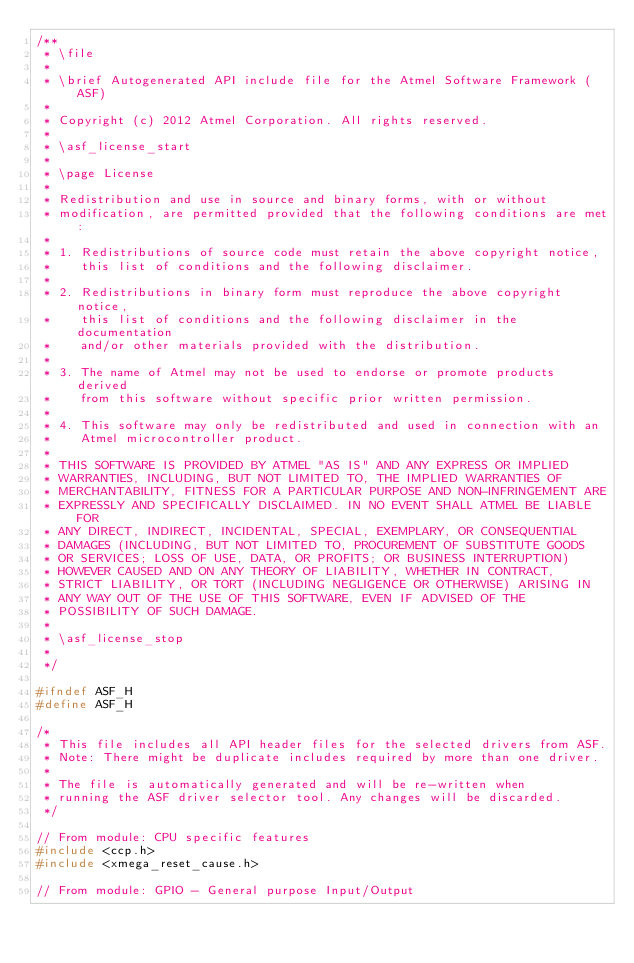Convert code to text. <code><loc_0><loc_0><loc_500><loc_500><_C_>/**
 * \file
 *
 * \brief Autogenerated API include file for the Atmel Software Framework (ASF)
 *
 * Copyright (c) 2012 Atmel Corporation. All rights reserved.
 *
 * \asf_license_start
 *
 * \page License
 *
 * Redistribution and use in source and binary forms, with or without
 * modification, are permitted provided that the following conditions are met:
 *
 * 1. Redistributions of source code must retain the above copyright notice,
 *    this list of conditions and the following disclaimer.
 *
 * 2. Redistributions in binary form must reproduce the above copyright notice,
 *    this list of conditions and the following disclaimer in the documentation
 *    and/or other materials provided with the distribution.
 *
 * 3. The name of Atmel may not be used to endorse or promote products derived
 *    from this software without specific prior written permission.
 *
 * 4. This software may only be redistributed and used in connection with an
 *    Atmel microcontroller product.
 *
 * THIS SOFTWARE IS PROVIDED BY ATMEL "AS IS" AND ANY EXPRESS OR IMPLIED
 * WARRANTIES, INCLUDING, BUT NOT LIMITED TO, THE IMPLIED WARRANTIES OF
 * MERCHANTABILITY, FITNESS FOR A PARTICULAR PURPOSE AND NON-INFRINGEMENT ARE
 * EXPRESSLY AND SPECIFICALLY DISCLAIMED. IN NO EVENT SHALL ATMEL BE LIABLE FOR
 * ANY DIRECT, INDIRECT, INCIDENTAL, SPECIAL, EXEMPLARY, OR CONSEQUENTIAL
 * DAMAGES (INCLUDING, BUT NOT LIMITED TO, PROCUREMENT OF SUBSTITUTE GOODS
 * OR SERVICES; LOSS OF USE, DATA, OR PROFITS; OR BUSINESS INTERRUPTION)
 * HOWEVER CAUSED AND ON ANY THEORY OF LIABILITY, WHETHER IN CONTRACT,
 * STRICT LIABILITY, OR TORT (INCLUDING NEGLIGENCE OR OTHERWISE) ARISING IN
 * ANY WAY OUT OF THE USE OF THIS SOFTWARE, EVEN IF ADVISED OF THE
 * POSSIBILITY OF SUCH DAMAGE.
 *
 * \asf_license_stop
 *
 */

#ifndef ASF_H
#define ASF_H

/*
 * This file includes all API header files for the selected drivers from ASF.
 * Note: There might be duplicate includes required by more than one driver.
 *
 * The file is automatically generated and will be re-written when
 * running the ASF driver selector tool. Any changes will be discarded.
 */

// From module: CPU specific features
#include <ccp.h>
#include <xmega_reset_cause.h>

// From module: GPIO - General purpose Input/Output</code> 